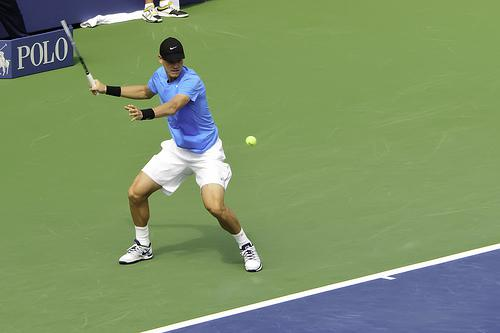Question: what brand name is shown?
Choices:
A. Lacoste.
B. POLO.
C. Nautica.
D. Brooks brothers.
Answer with the letter. Answer: B Question: where is there a nike sign?
Choices:
A. Hood.
B. Hat.
C. Shirt.
D. Pants.
Answer with the letter. Answer: B Question: what two things that the man is wearing match in color?
Choices:
A. Shorts and socks.
B. Socks and shoes.
C. Hat and shirt.
D. Gloves and jacket.
Answer with the letter. Answer: A Question: who is about to swing at the tennis ball?
Choices:
A. Man.
B. Woman.
C. Child.
D. Tennis player.
Answer with the letter. Answer: A 